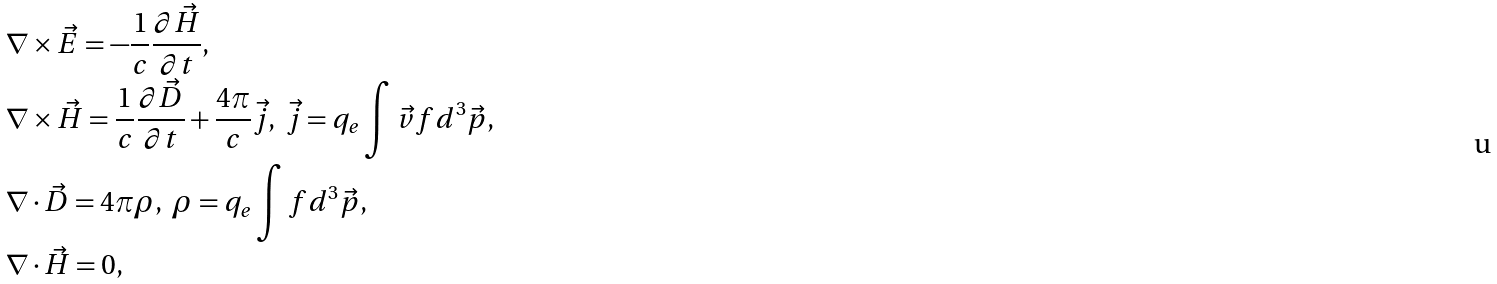<formula> <loc_0><loc_0><loc_500><loc_500>& \nabla \times \vec { E } = - \frac { 1 } { c } \frac { \partial \vec { H } } { \partial t } , \\ & \nabla \times \vec { H } = \frac { 1 } { c } \frac { \partial \vec { D } } { \partial t } + \frac { 4 \pi } { c } \vec { j } , \text { } \vec { j } = q _ { e } \int \vec { v } f d ^ { 3 } \vec { p } , \\ & \nabla \cdot \vec { D } = 4 \pi \rho , \text { } \rho = q _ { e } \int f d ^ { 3 } \vec { p } , \\ & \nabla \cdot \vec { H } = 0 , \\</formula> 